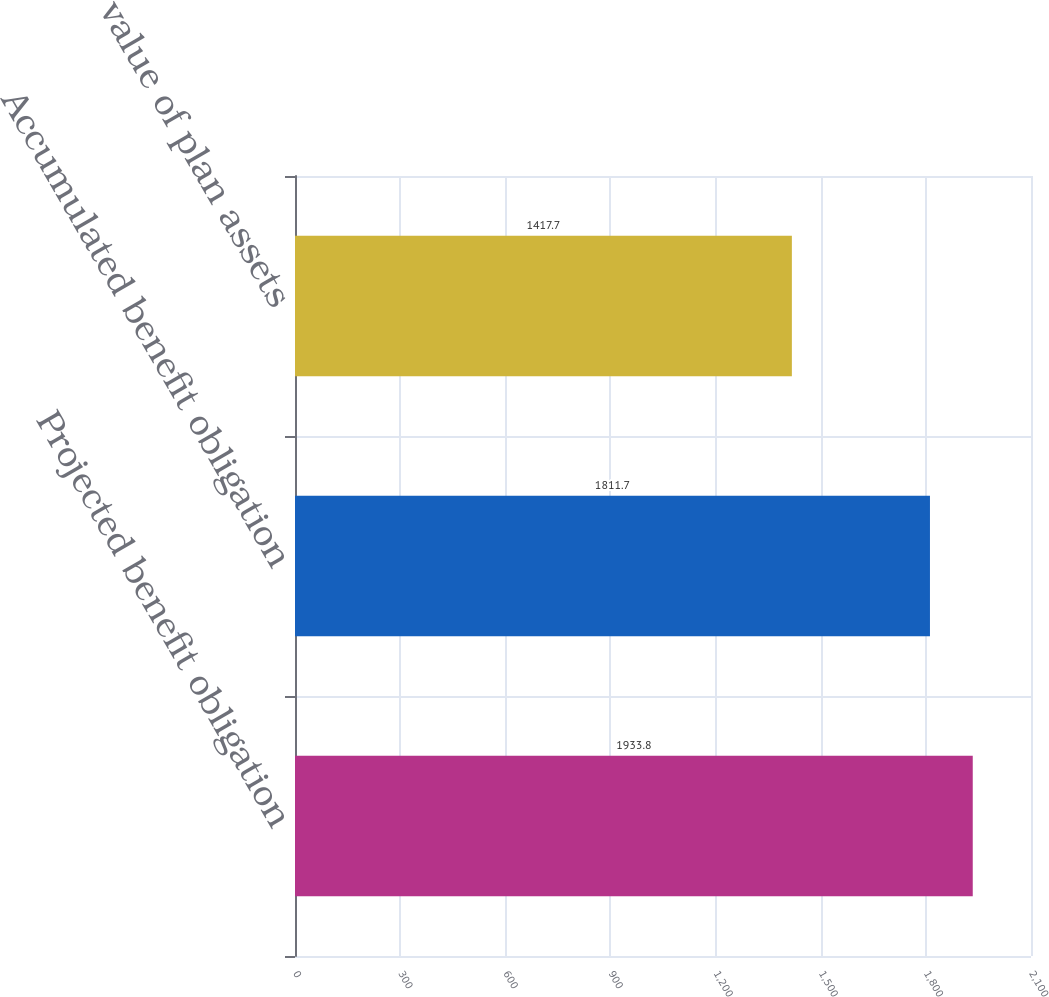Convert chart. <chart><loc_0><loc_0><loc_500><loc_500><bar_chart><fcel>Projected benefit obligation<fcel>Accumulated benefit obligation<fcel>Fair value of plan assets<nl><fcel>1933.8<fcel>1811.7<fcel>1417.7<nl></chart> 